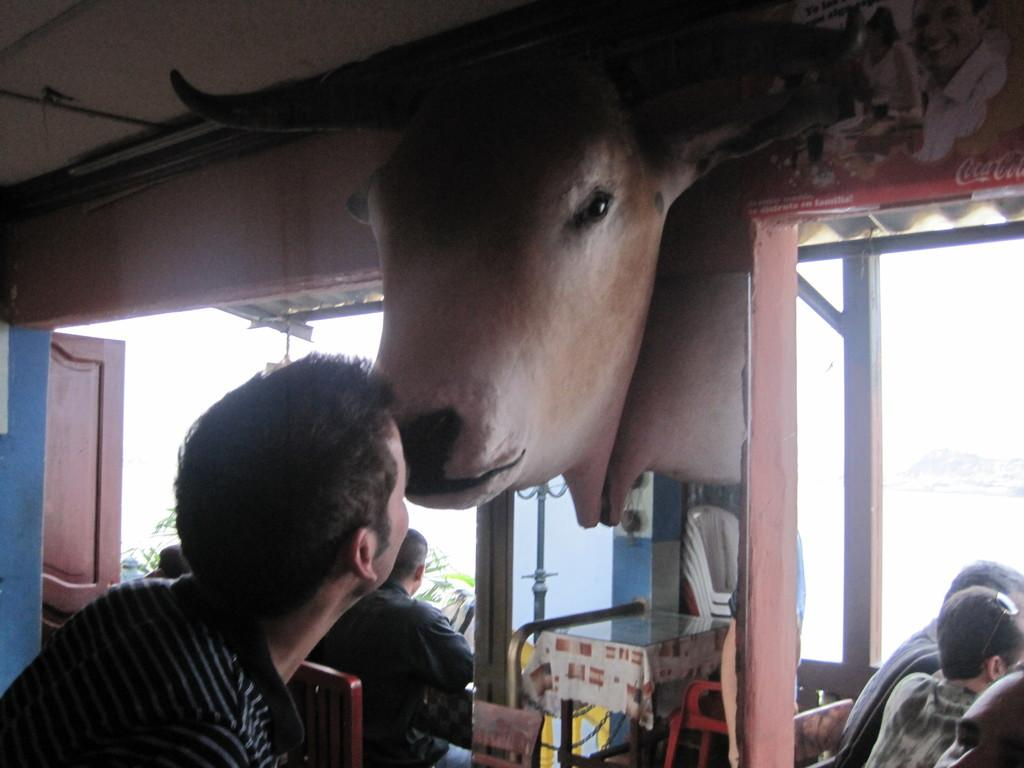How many people are present in the image? There are people in the image, but the exact number is not specified. What type of furniture is in the image? There is a table and chairs in the image. What material is present in the image? There is cloth in the image. What type of dishware is in the image? There are glasses in the image. What architectural feature is in the image? There is a door in the image. What decorative item is in the image? There is a statue of an animal face in the image. Can you tell me how many fans are in the image? There is no fan present in the image. What type of salt is sprinkled on the table in the image? There is no salt present in the image. 